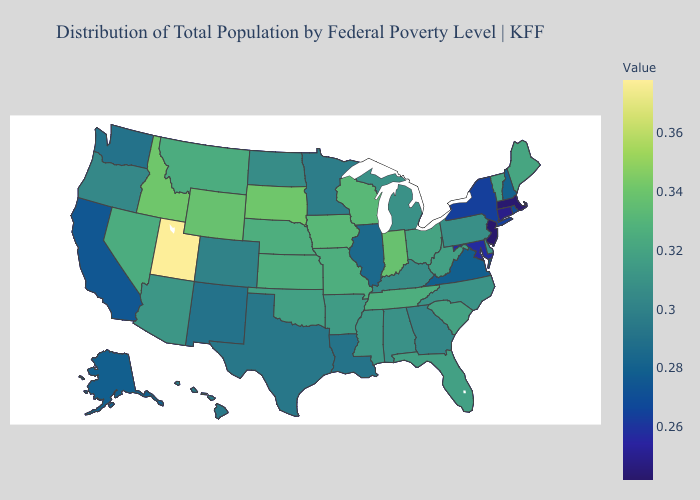Which states have the highest value in the USA?
Give a very brief answer. Utah. Does New Hampshire have a higher value than Connecticut?
Be succinct. Yes. Among the states that border South Dakota , which have the highest value?
Answer briefly. Wyoming. 